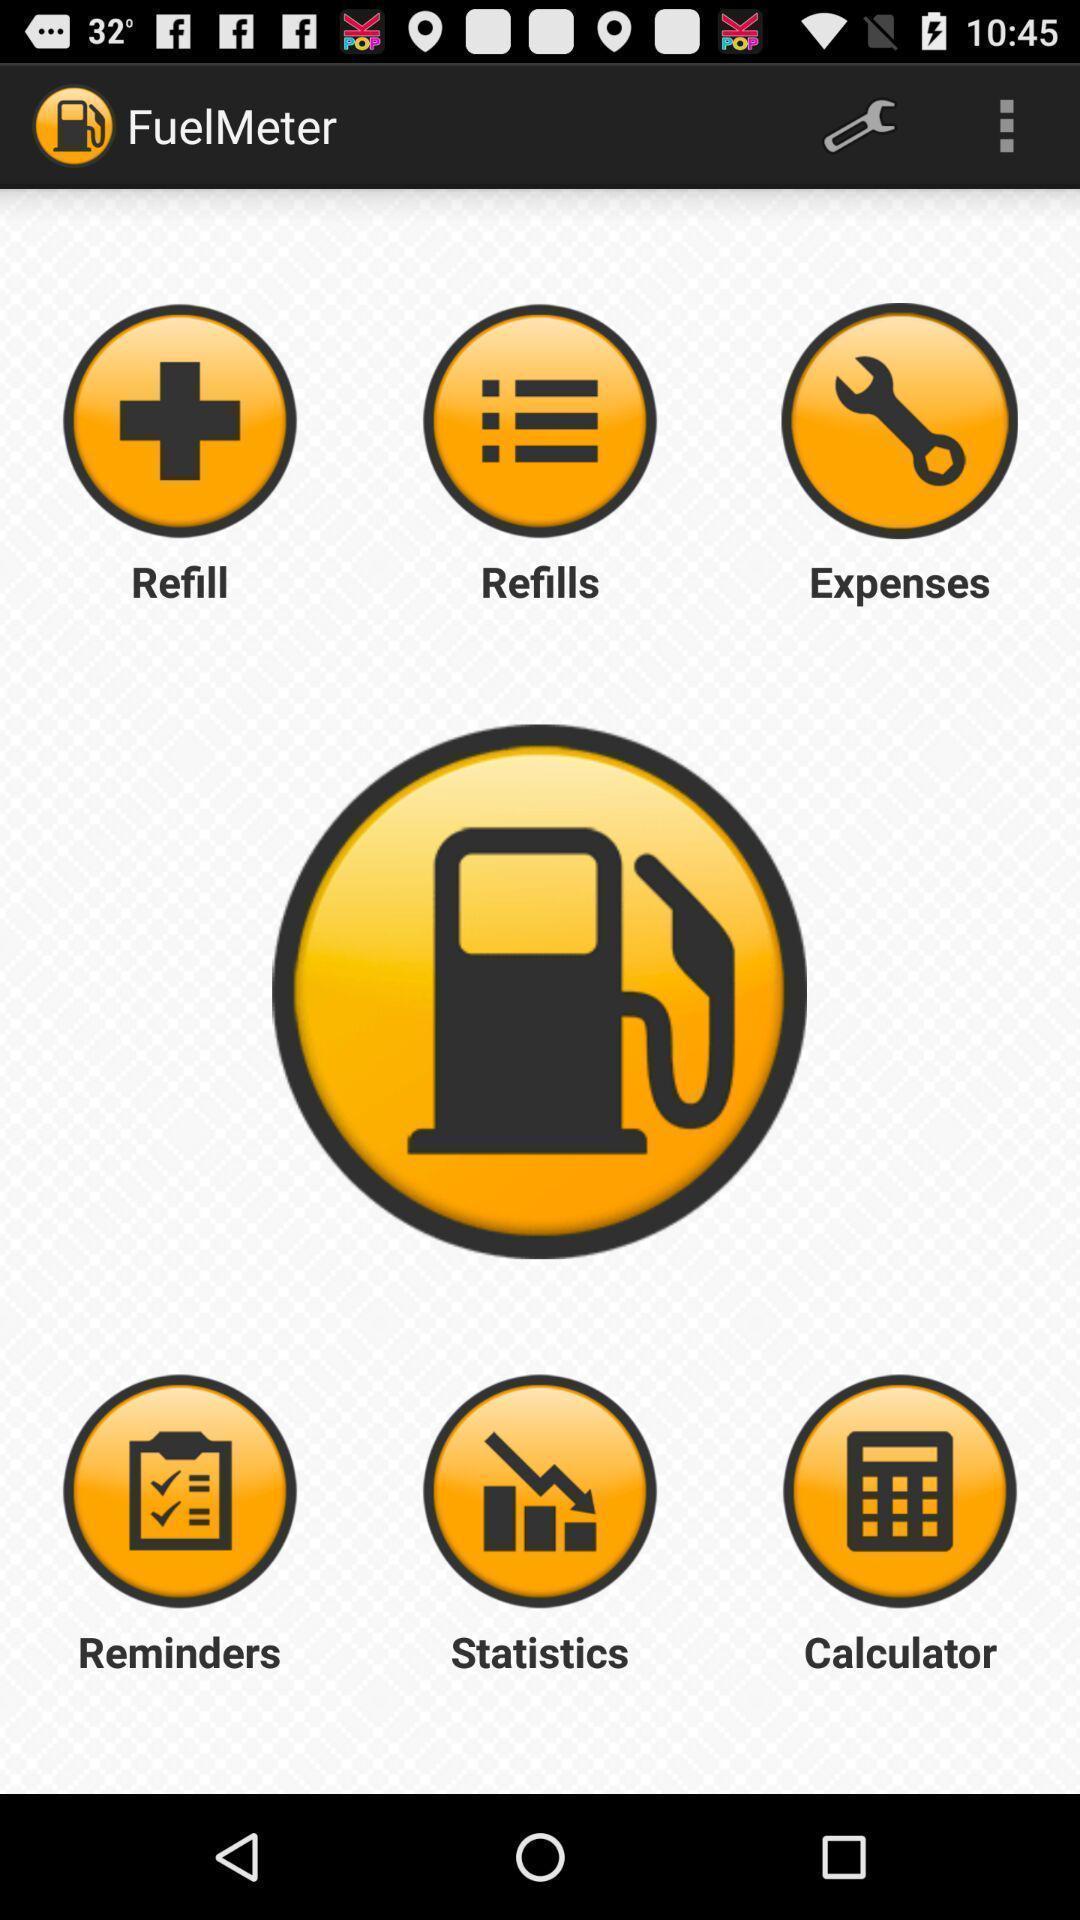Summarize the information in this screenshot. Social app showing the details of fuel meter. 